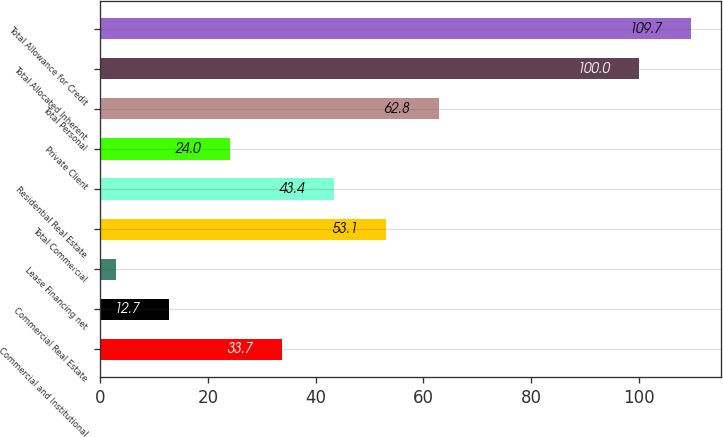Convert chart to OTSL. <chart><loc_0><loc_0><loc_500><loc_500><bar_chart><fcel>Commercial and Institutional<fcel>Commercial Real Estate<fcel>Lease Financing net<fcel>Total Commercial<fcel>Residential Real Estate<fcel>Private Client<fcel>Total Personal<fcel>Total Allocated Inherent<fcel>Total Allowance for Credit<nl><fcel>33.7<fcel>12.7<fcel>3<fcel>53.1<fcel>43.4<fcel>24<fcel>62.8<fcel>100<fcel>109.7<nl></chart> 